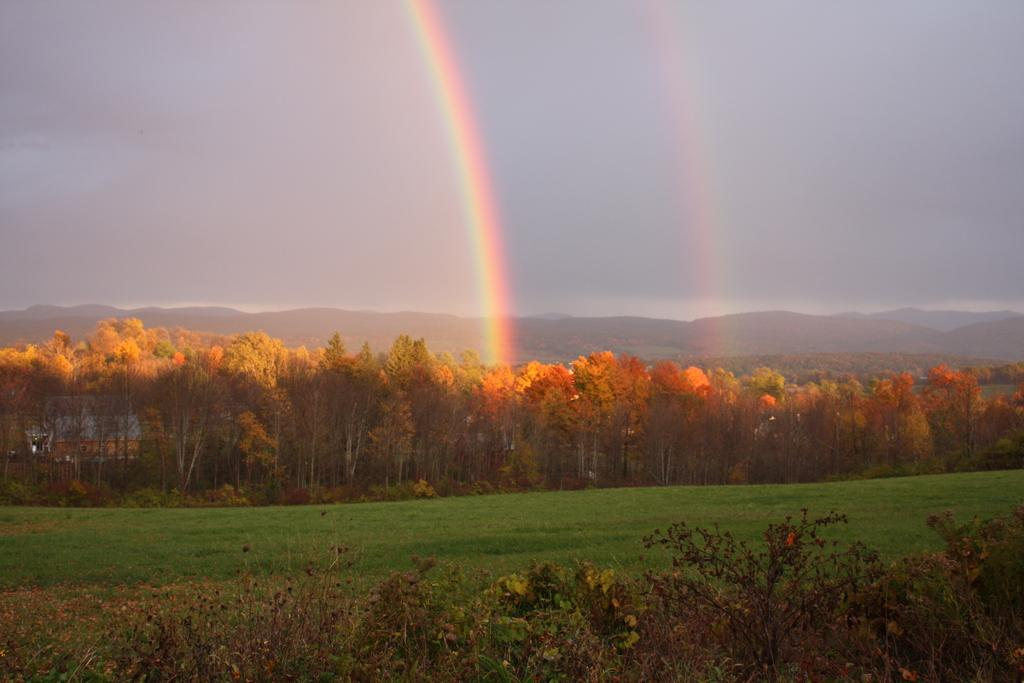What color are the trees in the image? The trees in the image are orange in color. What type of vegetation is present at the bottom of the image? There is green grass and plants at the bottom of the image. What can be seen in the sky in the background of the image? A rainbow is visible in the sky in the background of the image. What geographical feature is visible in the background of the image? There are mountains in the background of the image. Where is the zoo located in the image? There is no zoo present in the image. What type of bone can be seen in the image? There are no bones present in the image. 